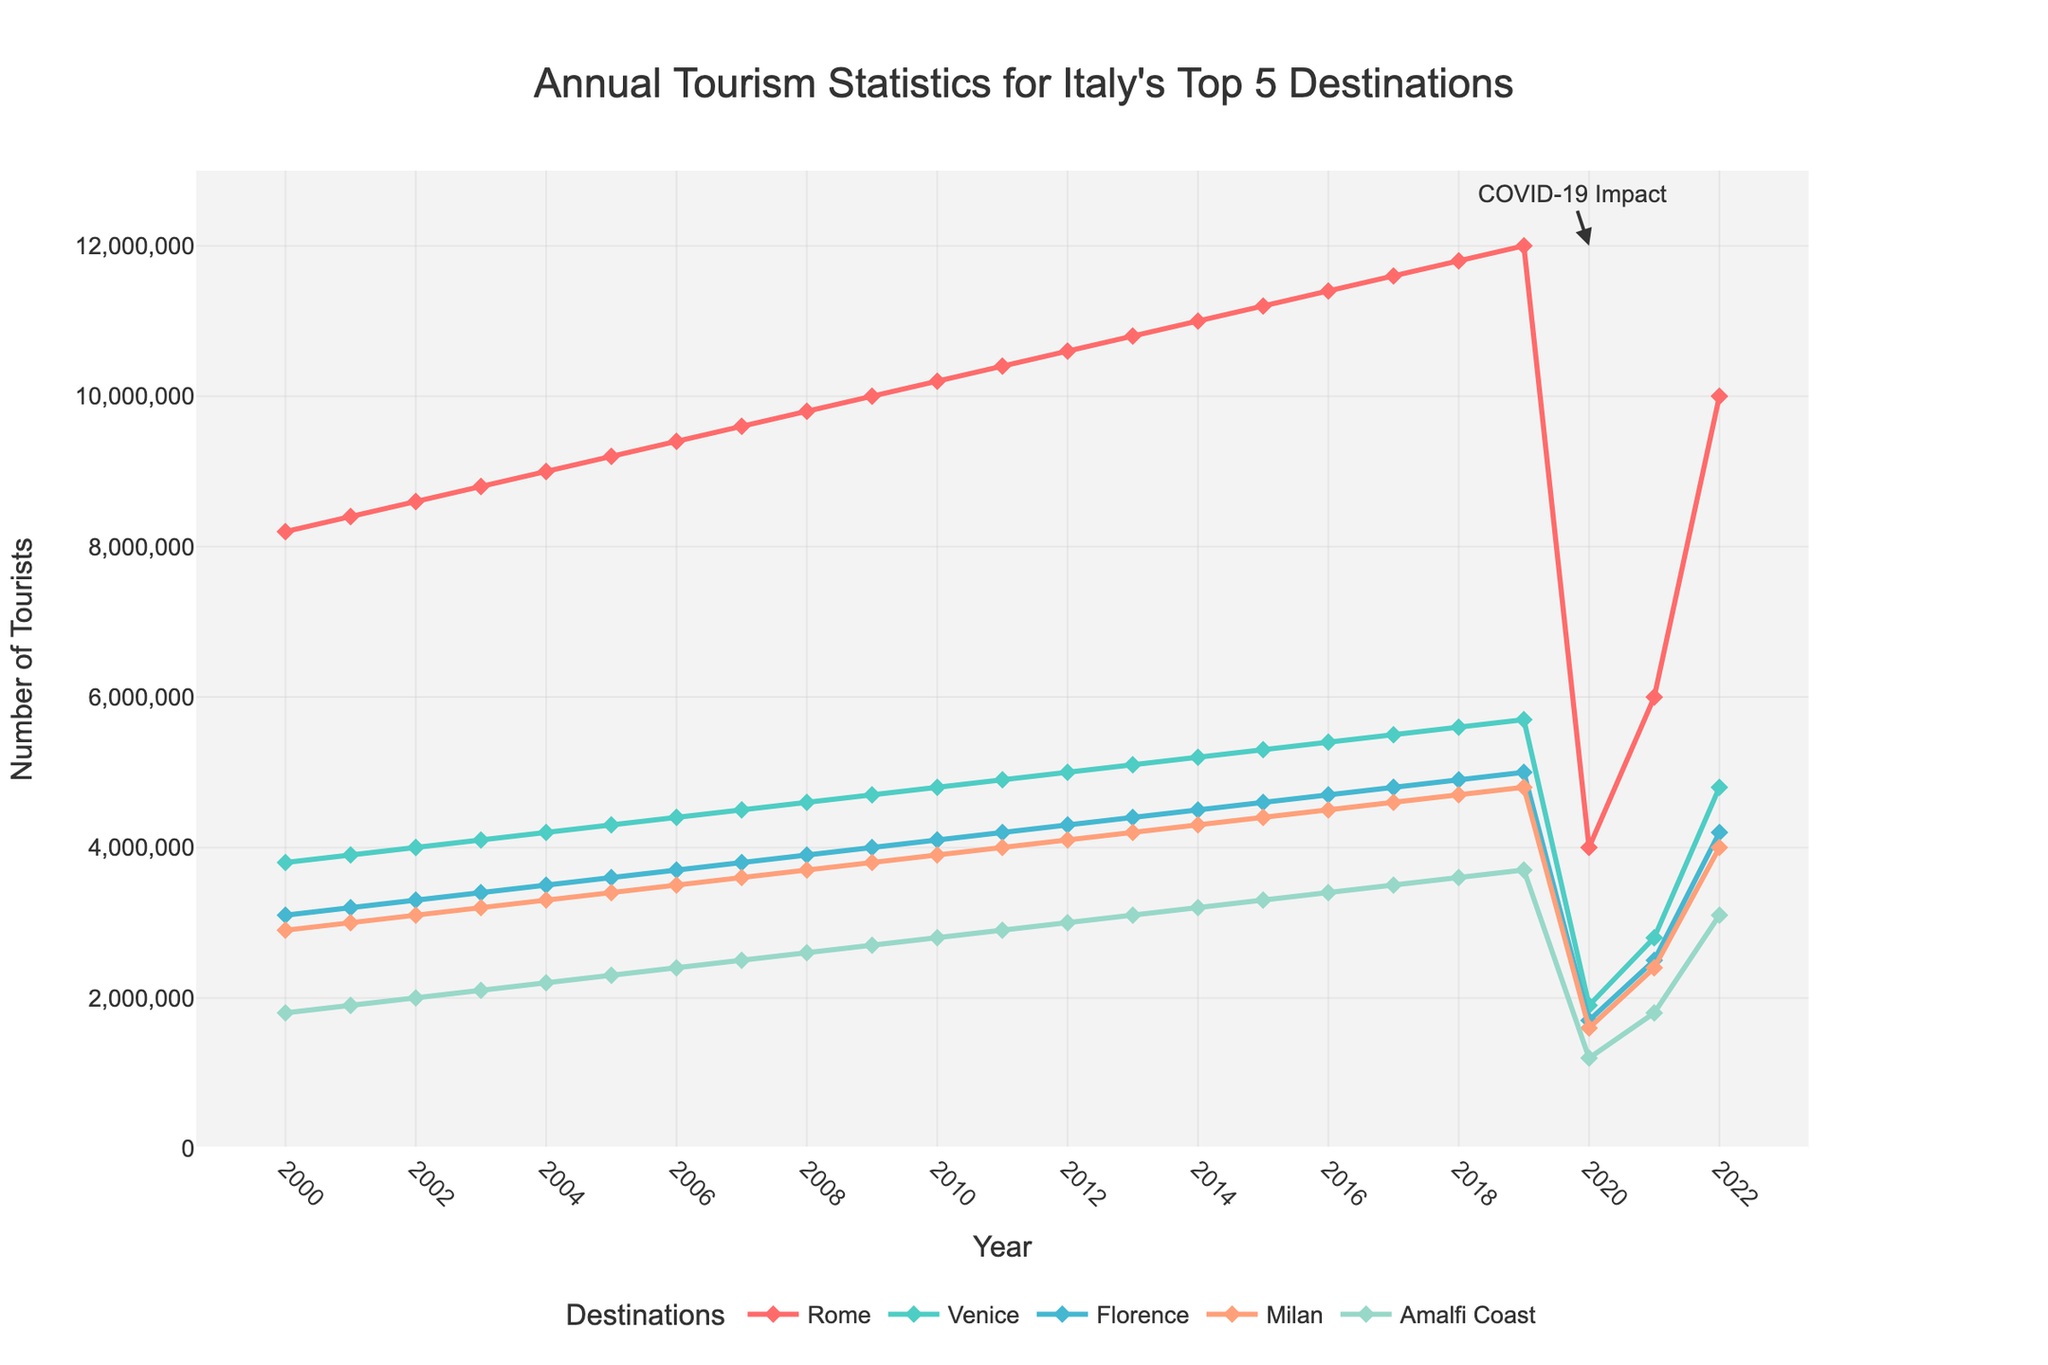what happened to tourism in 2020 for all destinations? By examining the figure, a substantial decline is observable across all destinations in 2020. This sharp reduction can be attributed to the COVID-19 pandemic, which significantly impacted global travel and tourism.
Answer: Significant decline due to COVID-19 compare the number of tourists in Rome and Venice in 2022? The number of tourists in Rome for 2022 appears to be around 10,000,000, whereas Venice has about 4,800,000 tourists as shown in the figure. Comparatively, Rome had a higher number of tourists than Venice in 2022.
Answer: Rome had more tourists what is the trend of tourism in Milan from 2000 to 2022? The figure shows an overall upward trajectory for the number of tourists in Milan from 2000 to 2019, peaking in 2019 at approximately 4,800,000. However, there is a substantial dip in 2020 and 2021 due to the COVID-19 pandemic, followed by a partial recovery in 2022.
Answer: Increasing trend till 2019, dip in 2020-2021, partial recovery in 2022 which city experienced the highest number of tourists in 2021? According to the figure, Rome had the highest number of tourists in 2021, with around 6,000,000 visitors.
Answer: Rome compare the recovery of tourism in Amalfi Coast and Florence from 2020 to 2022? The figure indicates that tourism in both Amalfi Coast and Florence showed a recovery from 2020 to 2022. Florence went from around 1,700,000 tourists in 2020 to approximately 4,200,000 in 2022, while Amalfi Coast increased from about 1,200,000 to around 3,100,000 tourists in the same period. Florence had a more significant rebound compared to Amalfi Coast.
Answer: Florence recovered more what is the approximate decrease in the number of tourists in Venice from 2019 to 2020? In 2019, Venice had about 5,700,000 tourists, which dropped to 1,900,000 in 2020. The decrease in the number of tourists is approximately 3,800,000.
Answer: 3,800,000 which city had the smallest number of tourists in 2015 and how many tourists did it have? The figure shows that the Amalfi Coast had the smallest number of tourists in 2015, with around 3,300,000 visitors.
Answer: Amalfi Coast, 3,300,000 what is the average number of tourists visiting Florence from 2000 to 2005? To find the average, sum the number of tourists in Florence from 2000 to 2005 (3,100,000 + 3,200,000 + 3,300,000 + 3,400,000 + 3,500,000 + 3,600,000) which equals 19,100,000, and then divide by 6. The average number of tourists is approximately 3,183,333.
Answer: 3,183,333 which destination had the most stable growth in tourism from 2000 to 2019? Analyzing the figure, Florence displays a stable and consistent growth in tourism from 2000 to 2019 without any sharp drops or spikes.
Answer: Florence 